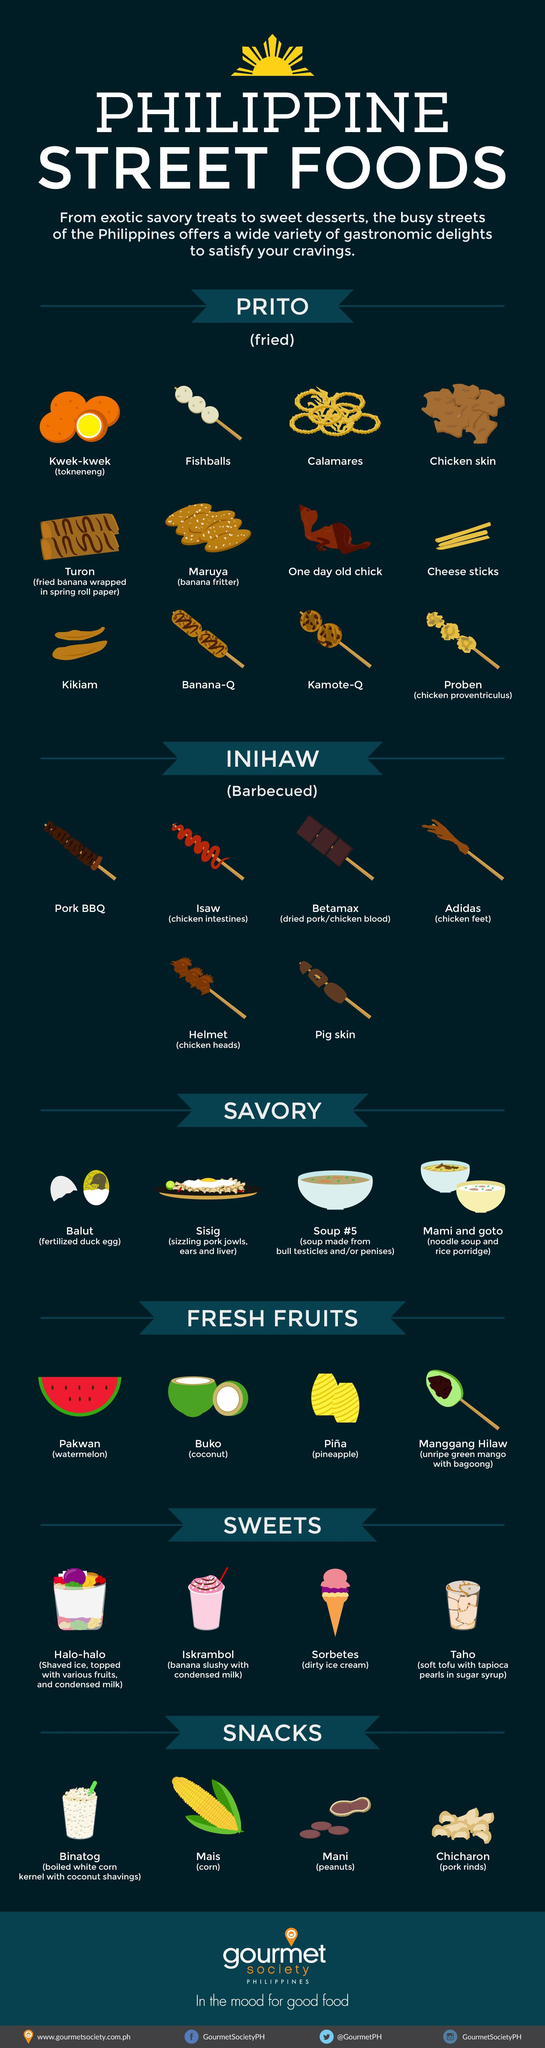Which are the desserts served with condensed milk in Phillipines?
Answer the question with a short phrase. Halo-halo, Iskrambol What is rice porridge called in Filipino, Mami, Goto, or Balut? Goto Which is the only non-veg snack in the list, Binatog, Mani, or Chicharon? Chicharon What is another name for Kwek- Kwek, Fishballs, Calamares, or Tokneneng? Tokneneng What is coconut known as in Filipino language, Pakwan, Buko, or Manggang? Buko Which are the two fried dishes that have banana as the main ingredient ? Turon, Maruya How many barbecue items are prepared using various parts of a chicken? 4 Which Filipino food shares it name with a shoe company? Adidas 